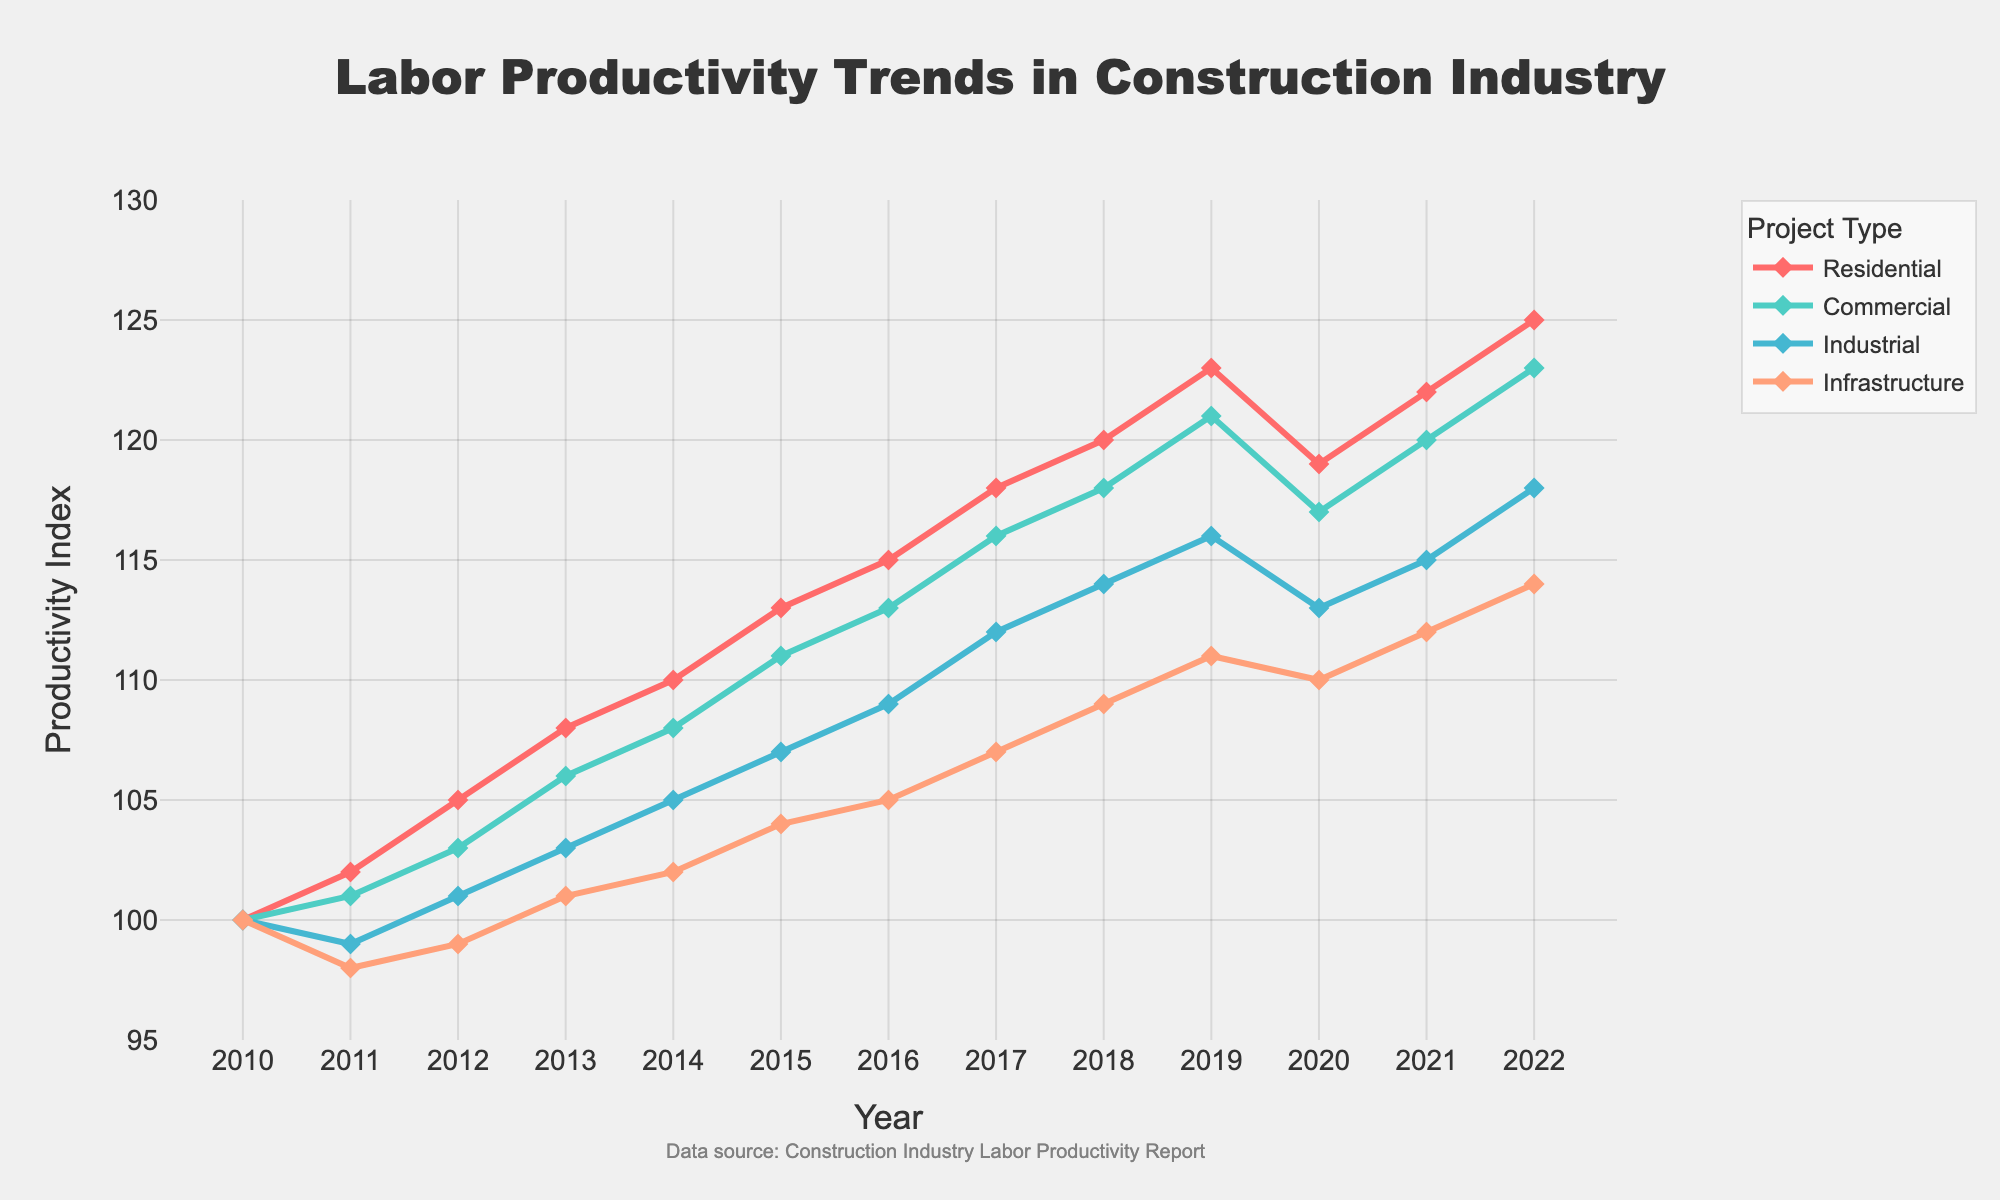What is the overall trend of labor productivity in the residential construction sector from 2010 to 2022? By inspecting the line representing the residential sector, it consistently rises from 100 in 2010 to 125 in 2022.
Answer: Upward Which project type experienced the most considerable dip in productivity between 2019 and 2020? Observing the lines, residential construction shows a drop from 123 in 2019 to 119 in 2020, more significant than the other sectors.
Answer: Residential In which year did the commercial construction productivity index surpass 110 for the first time? The commercial line crosses the 110 index between 2014 and 2015, specifically at 111 in 2015.
Answer: 2015 Compare the productivity index of industrial and infrastructure projects in 2014. Which one was higher? The indices can be seen at 105 for industrial and 102 for infrastructure in 2014.
Answer: Industrial What is the difference in the productivity index between the highest and lowest sectors in 2016? The highest is residential at 115, and the lowest is infrastructure at 105, so the difference is 115 - 105.
Answer: 10 What was the percentage change in infrastructure productivity from 2010 to 2022? Starting at 100 in 2010 and rising to 114 in 2022, the percentage change is calculated as ((114 - 100) / 100) * 100.
Answer: 14% Which project type shows the most stable productivity trend without significant fluctuations? By observing the lines, the infrastructure sector appears to have the least variability in its trend.
Answer: Infrastructure In which range did labor productivity for commercial construction lie from 2010 to 2022? The productivity index for commercial construction starts at 100 in 2010 and reaches 123 in 2022.
Answer: 100 to 123 During which year did all project types except for residential show a decline in productivity compared to their previous year? Evaluating the trends, only the year 2010-2011 shows a general decline for all except residential.
Answer: 2011 What was the average productivity index for the industrial sector between 2010 and 2022? Summing the productivity indices from 2010 to 2022 for the industrial sector (100 + 99 + 101 + 103 + 105 + 107 + 109 + 112 + 114 + 116 + 113 + 115 + 118) and dividing by the count (13) gives the average.
Answer: 108.23 